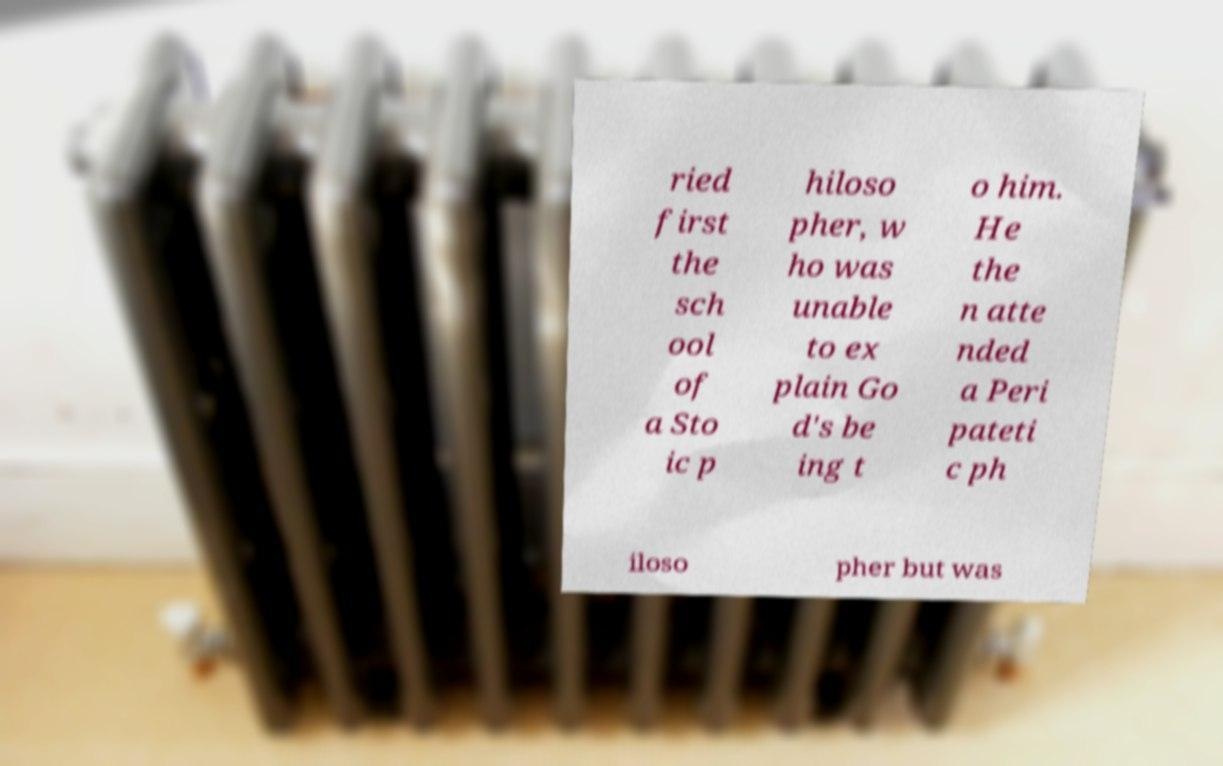For documentation purposes, I need the text within this image transcribed. Could you provide that? ried first the sch ool of a Sto ic p hiloso pher, w ho was unable to ex plain Go d's be ing t o him. He the n atte nded a Peri pateti c ph iloso pher but was 